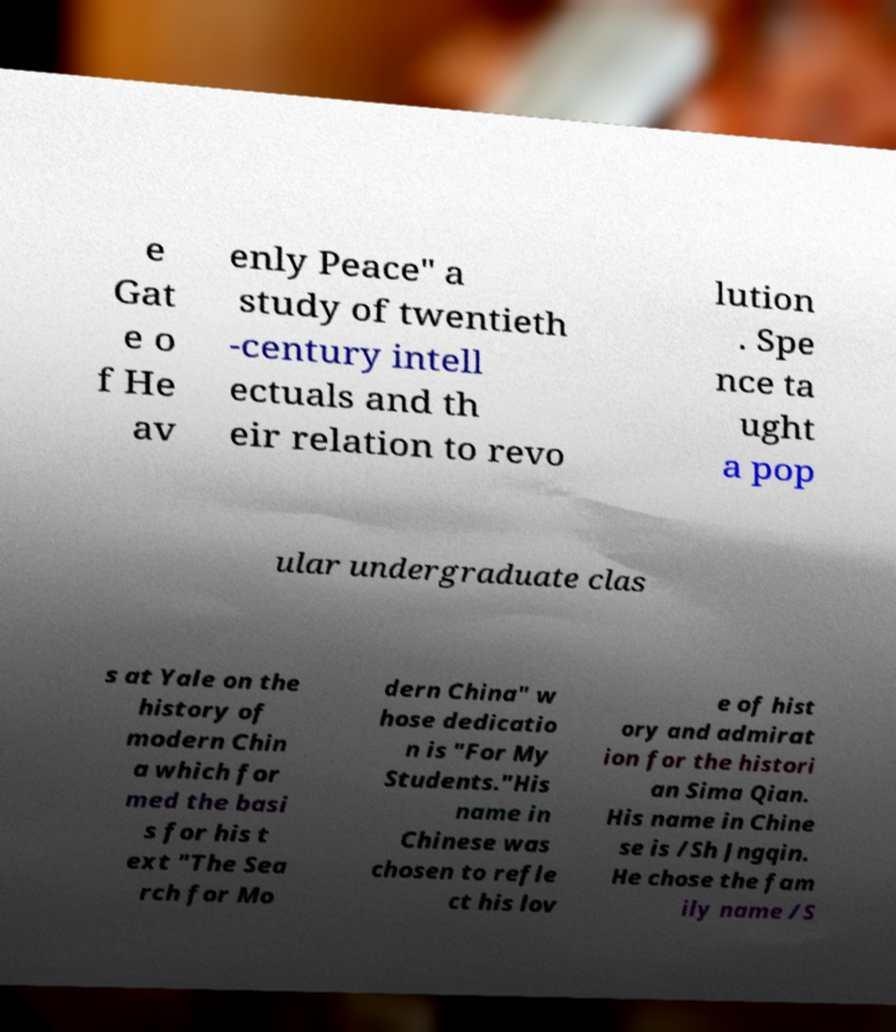Could you extract and type out the text from this image? e Gat e o f He av enly Peace" a study of twentieth -century intell ectuals and th eir relation to revo lution . Spe nce ta ught a pop ular undergraduate clas s at Yale on the history of modern Chin a which for med the basi s for his t ext "The Sea rch for Mo dern China" w hose dedicatio n is "For My Students."His name in Chinese was chosen to refle ct his lov e of hist ory and admirat ion for the histori an Sima Qian. His name in Chine se is /Sh Jngqin. He chose the fam ily name /S 